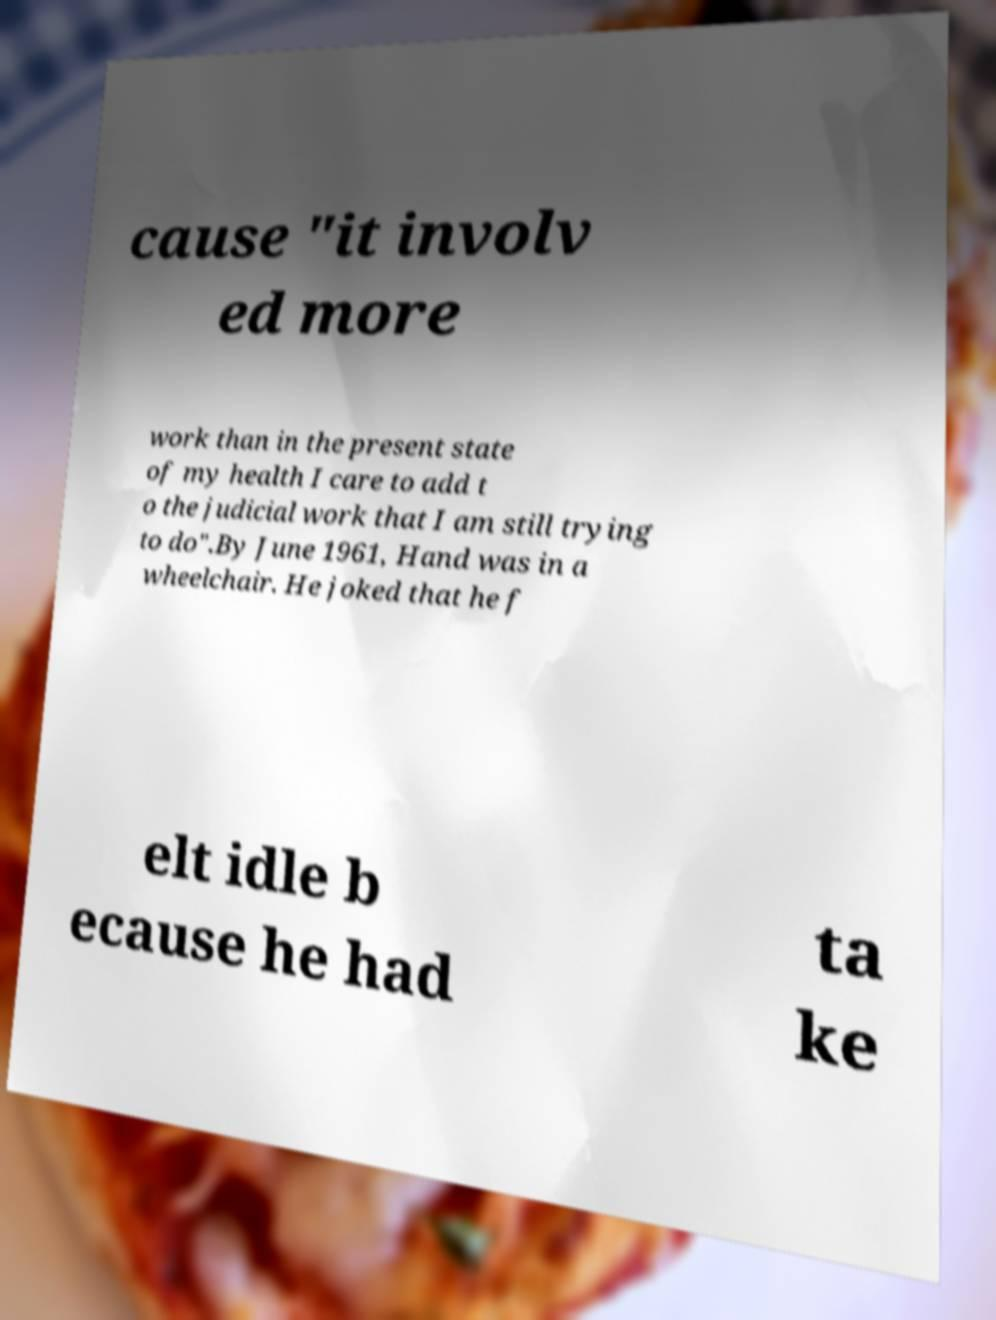What messages or text are displayed in this image? I need them in a readable, typed format. cause "it involv ed more work than in the present state of my health I care to add t o the judicial work that I am still trying to do".By June 1961, Hand was in a wheelchair. He joked that he f elt idle b ecause he had ta ke 